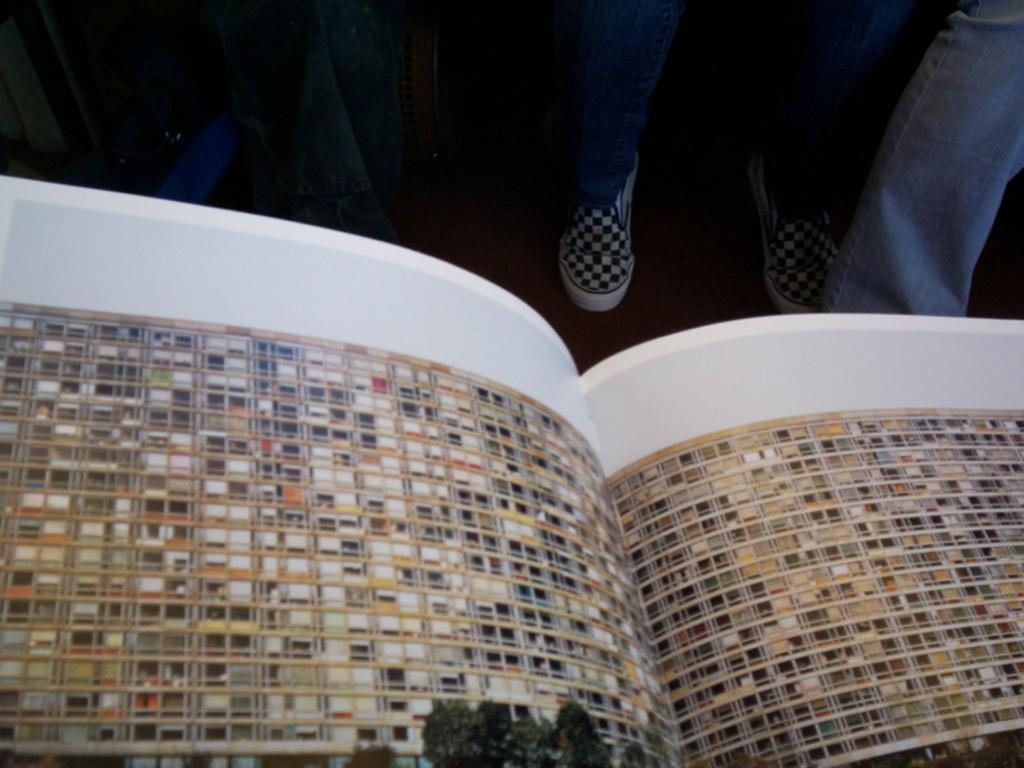What type of furniture is present in the image? There are tables in the image. What are the people in the image doing? The people are standing behind the tables. What type of salt is sprinkled on the button in the image? There is no salt or button present in the image. What is the color of the nose on the person standing behind the table? There is no nose visible on the person in the image, as the image only shows them from behind. 